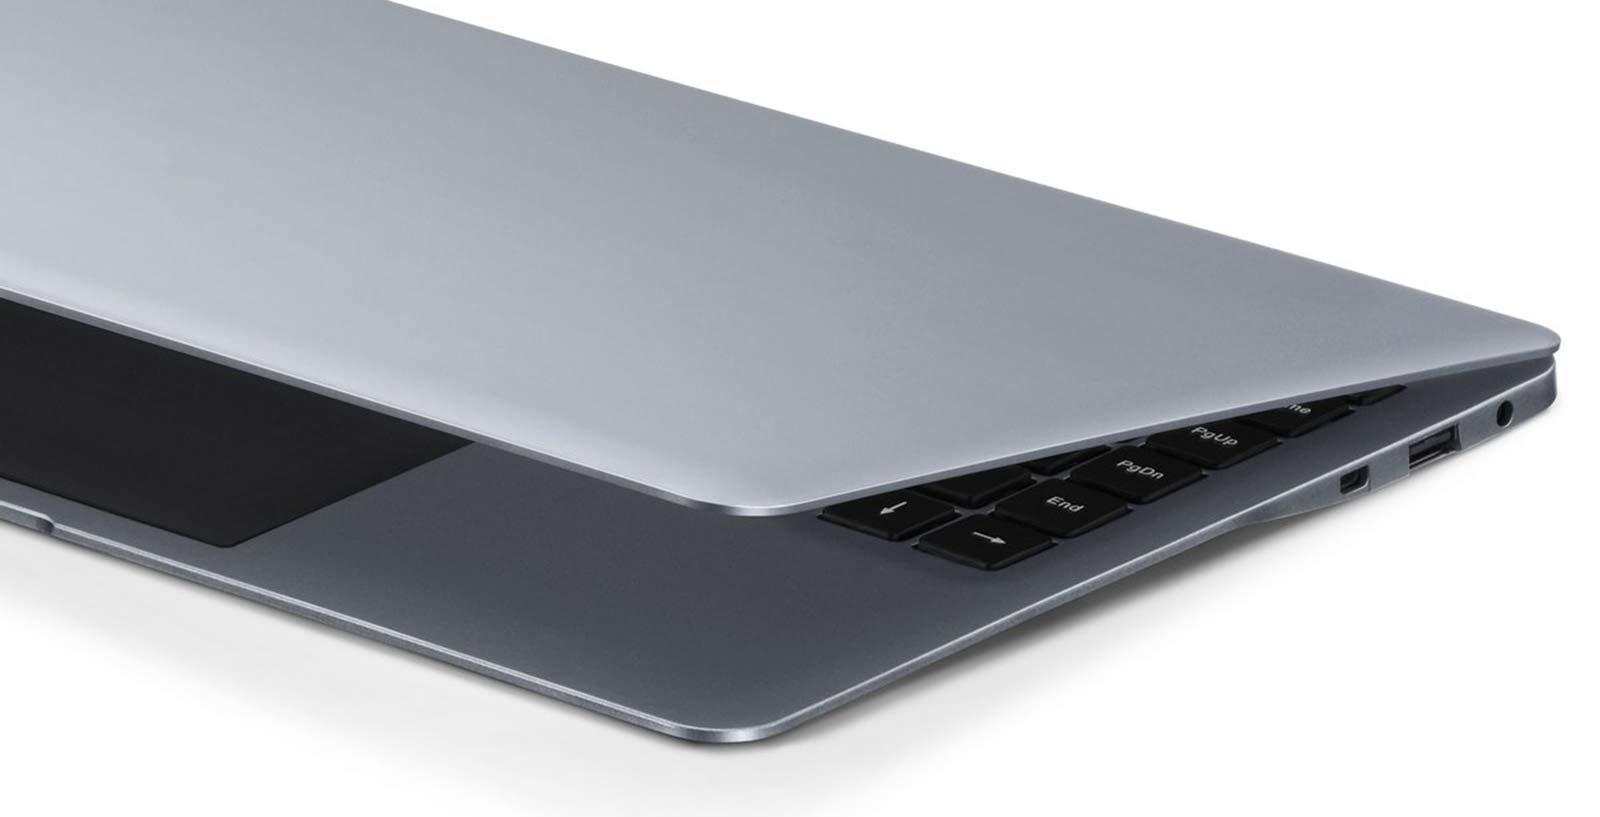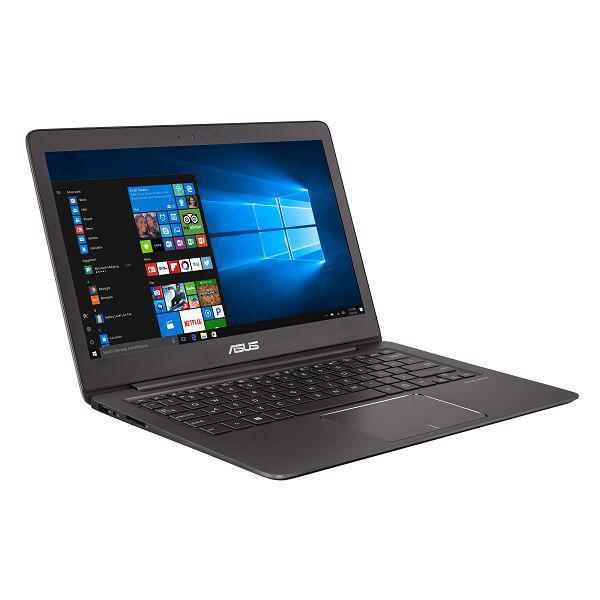The first image is the image on the left, the second image is the image on the right. Assess this claim about the two images: "One image shows an open laptop angled facing leftward, and the other image includes a head-on aerial view of an open laptop.". Correct or not? Answer yes or no. No. The first image is the image on the left, the second image is the image on the right. Examine the images to the left and right. Is the description "There are two screens in one of the images." accurate? Answer yes or no. No. 